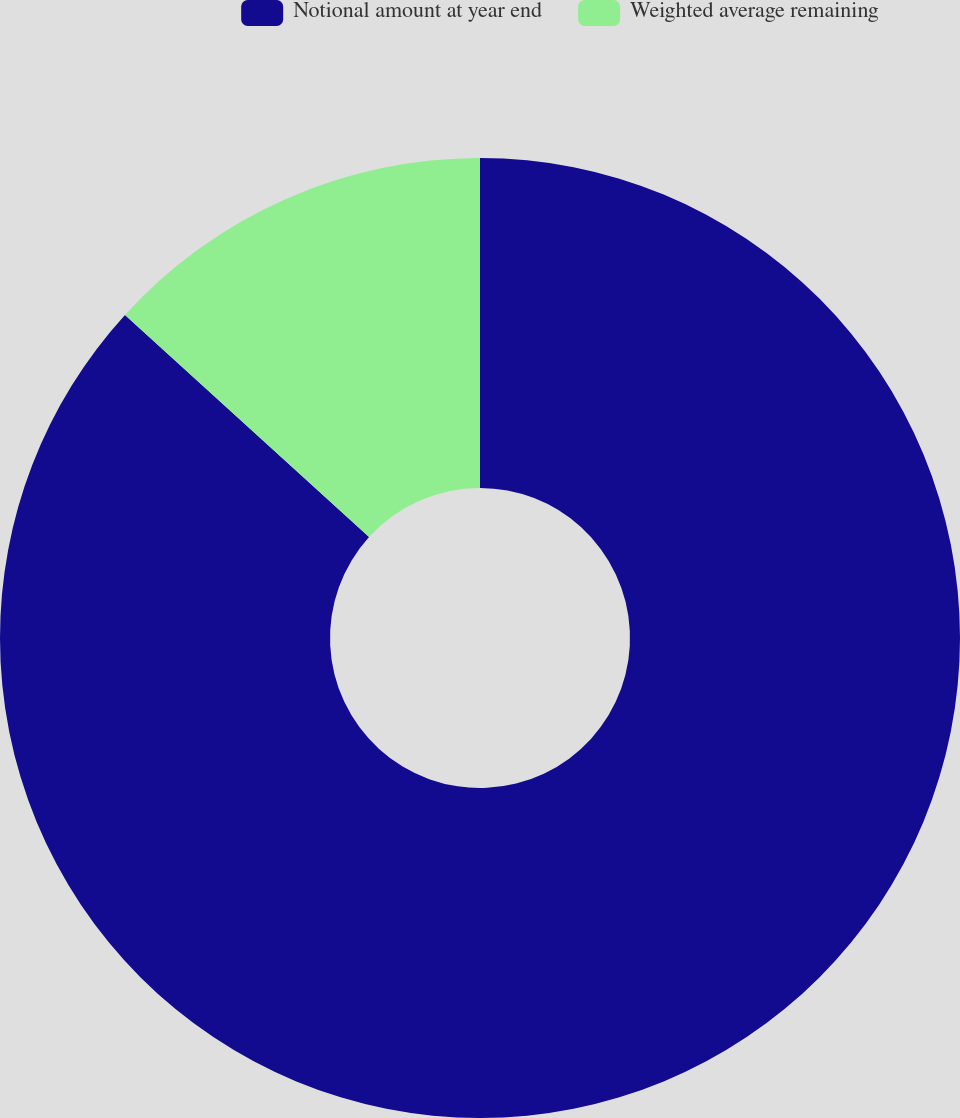Convert chart to OTSL. <chart><loc_0><loc_0><loc_500><loc_500><pie_chart><fcel>Notional amount at year end<fcel>Weighted average remaining<nl><fcel>86.75%<fcel>13.25%<nl></chart> 